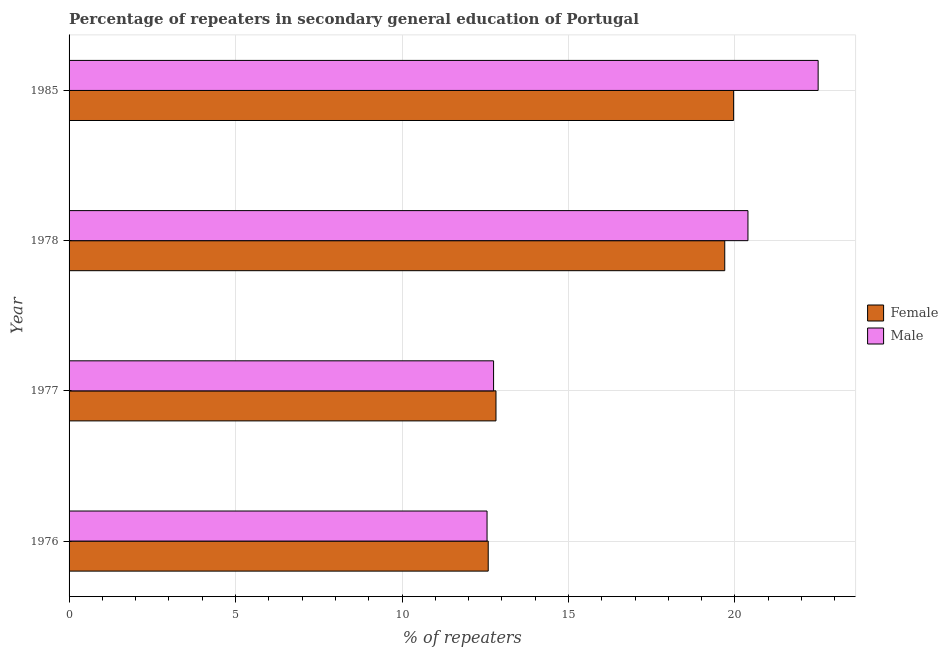How many different coloured bars are there?
Your answer should be very brief. 2. How many groups of bars are there?
Offer a terse response. 4. What is the label of the 2nd group of bars from the top?
Ensure brevity in your answer.  1978. In how many cases, is the number of bars for a given year not equal to the number of legend labels?
Give a very brief answer. 0. What is the percentage of male repeaters in 1985?
Offer a terse response. 22.5. Across all years, what is the maximum percentage of female repeaters?
Your response must be concise. 19.96. Across all years, what is the minimum percentage of male repeaters?
Your answer should be compact. 12.55. In which year was the percentage of male repeaters maximum?
Provide a short and direct response. 1985. In which year was the percentage of female repeaters minimum?
Your response must be concise. 1976. What is the total percentage of female repeaters in the graph?
Offer a terse response. 65.06. What is the difference between the percentage of female repeaters in 1976 and that in 1978?
Your answer should be compact. -7.1. What is the difference between the percentage of female repeaters in 1978 and the percentage of male repeaters in 1977?
Your answer should be very brief. 6.94. What is the average percentage of female repeaters per year?
Your answer should be very brief. 16.27. In the year 1977, what is the difference between the percentage of male repeaters and percentage of female repeaters?
Your answer should be compact. -0.07. In how many years, is the percentage of female repeaters greater than 3 %?
Your answer should be compact. 4. Is the percentage of female repeaters in 1977 less than that in 1985?
Keep it short and to the point. Yes. What is the difference between the highest and the second highest percentage of female repeaters?
Provide a succinct answer. 0.27. What is the difference between the highest and the lowest percentage of female repeaters?
Make the answer very short. 7.37. In how many years, is the percentage of male repeaters greater than the average percentage of male repeaters taken over all years?
Offer a terse response. 2. Is the sum of the percentage of male repeaters in 1976 and 1978 greater than the maximum percentage of female repeaters across all years?
Your response must be concise. Yes. What does the 1st bar from the top in 1978 represents?
Provide a succinct answer. Male. What does the 2nd bar from the bottom in 1985 represents?
Provide a short and direct response. Male. Are all the bars in the graph horizontal?
Give a very brief answer. Yes. Are the values on the major ticks of X-axis written in scientific E-notation?
Offer a terse response. No. Does the graph contain any zero values?
Offer a very short reply. No. Where does the legend appear in the graph?
Keep it short and to the point. Center right. What is the title of the graph?
Offer a very short reply. Percentage of repeaters in secondary general education of Portugal. What is the label or title of the X-axis?
Your answer should be compact. % of repeaters. What is the % of repeaters of Female in 1976?
Your response must be concise. 12.59. What is the % of repeaters in Male in 1976?
Offer a very short reply. 12.55. What is the % of repeaters of Female in 1977?
Your answer should be very brief. 12.82. What is the % of repeaters in Male in 1977?
Offer a very short reply. 12.75. What is the % of repeaters of Female in 1978?
Offer a very short reply. 19.69. What is the % of repeaters of Male in 1978?
Your response must be concise. 20.39. What is the % of repeaters in Female in 1985?
Your answer should be very brief. 19.96. What is the % of repeaters in Male in 1985?
Make the answer very short. 22.5. Across all years, what is the maximum % of repeaters in Female?
Provide a short and direct response. 19.96. Across all years, what is the maximum % of repeaters of Male?
Your answer should be compact. 22.5. Across all years, what is the minimum % of repeaters of Female?
Ensure brevity in your answer.  12.59. Across all years, what is the minimum % of repeaters of Male?
Your answer should be very brief. 12.55. What is the total % of repeaters of Female in the graph?
Offer a terse response. 65.06. What is the total % of repeaters of Male in the graph?
Make the answer very short. 68.19. What is the difference between the % of repeaters in Female in 1976 and that in 1977?
Make the answer very short. -0.23. What is the difference between the % of repeaters in Male in 1976 and that in 1977?
Provide a succinct answer. -0.2. What is the difference between the % of repeaters of Female in 1976 and that in 1978?
Offer a terse response. -7.1. What is the difference between the % of repeaters in Male in 1976 and that in 1978?
Your response must be concise. -7.84. What is the difference between the % of repeaters in Female in 1976 and that in 1985?
Give a very brief answer. -7.37. What is the difference between the % of repeaters in Male in 1976 and that in 1985?
Provide a succinct answer. -9.94. What is the difference between the % of repeaters in Female in 1977 and that in 1978?
Your answer should be compact. -6.87. What is the difference between the % of repeaters of Male in 1977 and that in 1978?
Make the answer very short. -7.64. What is the difference between the % of repeaters of Female in 1977 and that in 1985?
Make the answer very short. -7.14. What is the difference between the % of repeaters in Male in 1977 and that in 1985?
Keep it short and to the point. -9.75. What is the difference between the % of repeaters of Female in 1978 and that in 1985?
Your response must be concise. -0.27. What is the difference between the % of repeaters of Male in 1978 and that in 1985?
Offer a terse response. -2.11. What is the difference between the % of repeaters in Female in 1976 and the % of repeaters in Male in 1977?
Offer a terse response. -0.16. What is the difference between the % of repeaters in Female in 1976 and the % of repeaters in Male in 1978?
Ensure brevity in your answer.  -7.8. What is the difference between the % of repeaters of Female in 1976 and the % of repeaters of Male in 1985?
Your answer should be compact. -9.91. What is the difference between the % of repeaters in Female in 1977 and the % of repeaters in Male in 1978?
Provide a short and direct response. -7.57. What is the difference between the % of repeaters of Female in 1977 and the % of repeaters of Male in 1985?
Your answer should be very brief. -9.68. What is the difference between the % of repeaters of Female in 1978 and the % of repeaters of Male in 1985?
Provide a short and direct response. -2.8. What is the average % of repeaters of Female per year?
Your response must be concise. 16.27. What is the average % of repeaters of Male per year?
Provide a short and direct response. 17.05. In the year 1976, what is the difference between the % of repeaters of Female and % of repeaters of Male?
Ensure brevity in your answer.  0.04. In the year 1977, what is the difference between the % of repeaters of Female and % of repeaters of Male?
Your answer should be compact. 0.07. In the year 1978, what is the difference between the % of repeaters in Female and % of repeaters in Male?
Ensure brevity in your answer.  -0.7. In the year 1985, what is the difference between the % of repeaters of Female and % of repeaters of Male?
Provide a short and direct response. -2.54. What is the ratio of the % of repeaters of Female in 1976 to that in 1977?
Keep it short and to the point. 0.98. What is the ratio of the % of repeaters of Male in 1976 to that in 1977?
Your answer should be very brief. 0.98. What is the ratio of the % of repeaters of Female in 1976 to that in 1978?
Make the answer very short. 0.64. What is the ratio of the % of repeaters in Male in 1976 to that in 1978?
Your response must be concise. 0.62. What is the ratio of the % of repeaters of Female in 1976 to that in 1985?
Your answer should be very brief. 0.63. What is the ratio of the % of repeaters in Male in 1976 to that in 1985?
Offer a terse response. 0.56. What is the ratio of the % of repeaters of Female in 1977 to that in 1978?
Provide a short and direct response. 0.65. What is the ratio of the % of repeaters of Male in 1977 to that in 1978?
Provide a short and direct response. 0.63. What is the ratio of the % of repeaters in Female in 1977 to that in 1985?
Give a very brief answer. 0.64. What is the ratio of the % of repeaters of Male in 1977 to that in 1985?
Keep it short and to the point. 0.57. What is the ratio of the % of repeaters in Female in 1978 to that in 1985?
Your answer should be very brief. 0.99. What is the ratio of the % of repeaters in Male in 1978 to that in 1985?
Make the answer very short. 0.91. What is the difference between the highest and the second highest % of repeaters of Female?
Give a very brief answer. 0.27. What is the difference between the highest and the second highest % of repeaters in Male?
Provide a succinct answer. 2.11. What is the difference between the highest and the lowest % of repeaters of Female?
Offer a very short reply. 7.37. What is the difference between the highest and the lowest % of repeaters of Male?
Make the answer very short. 9.94. 